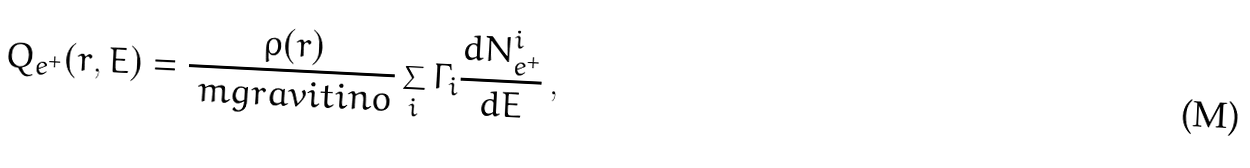Convert formula to latex. <formula><loc_0><loc_0><loc_500><loc_500>Q _ { e ^ { + } } ( r , E ) = \frac { \rho ( r ) } { \ m g r a v i t i n o } \sum _ { i } \Gamma _ { i } \frac { d N _ { e ^ { + } } ^ { i } } { d E } \, ,</formula> 